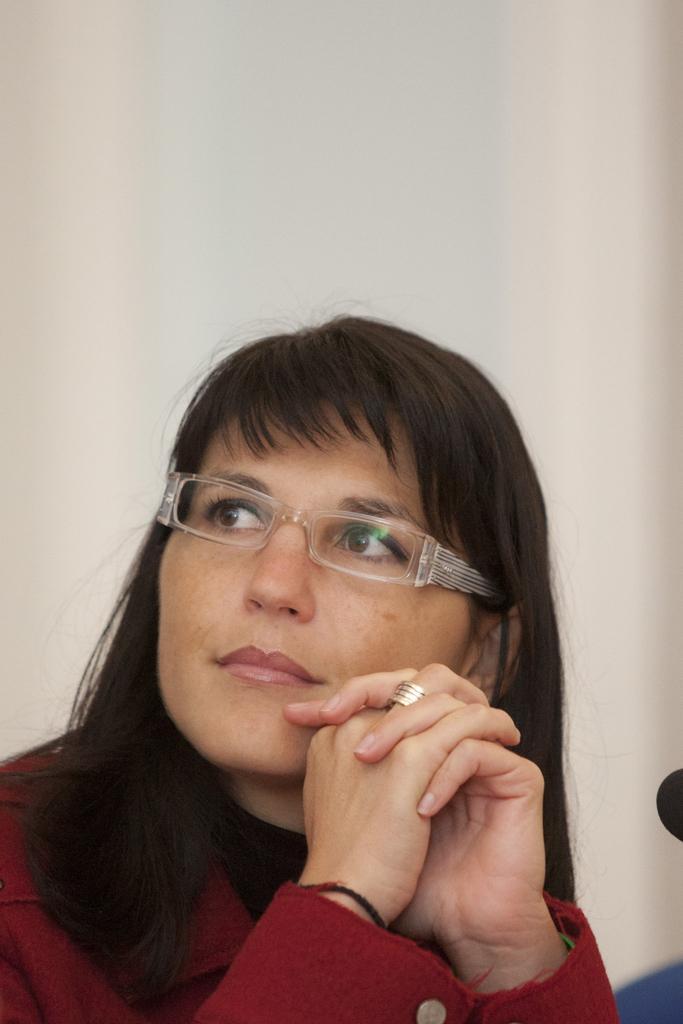Describe this image in one or two sentences. In this picture I can observe a woman. She is wearing maroon color dress and spectacles. The background is in white color. 